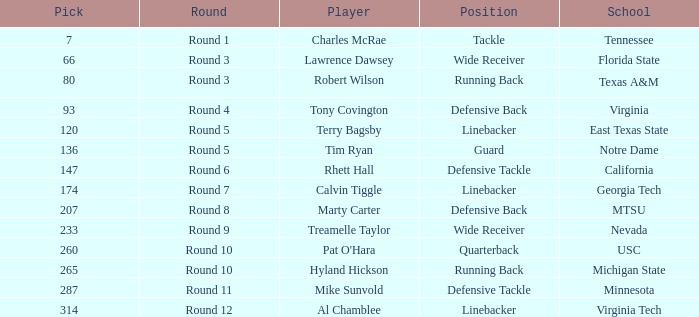What role did the athlete from east texas state perform? Linebacker. 